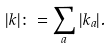Convert formula to latex. <formula><loc_0><loc_0><loc_500><loc_500>| k | \colon = \sum _ { a } | k _ { a } | .</formula> 